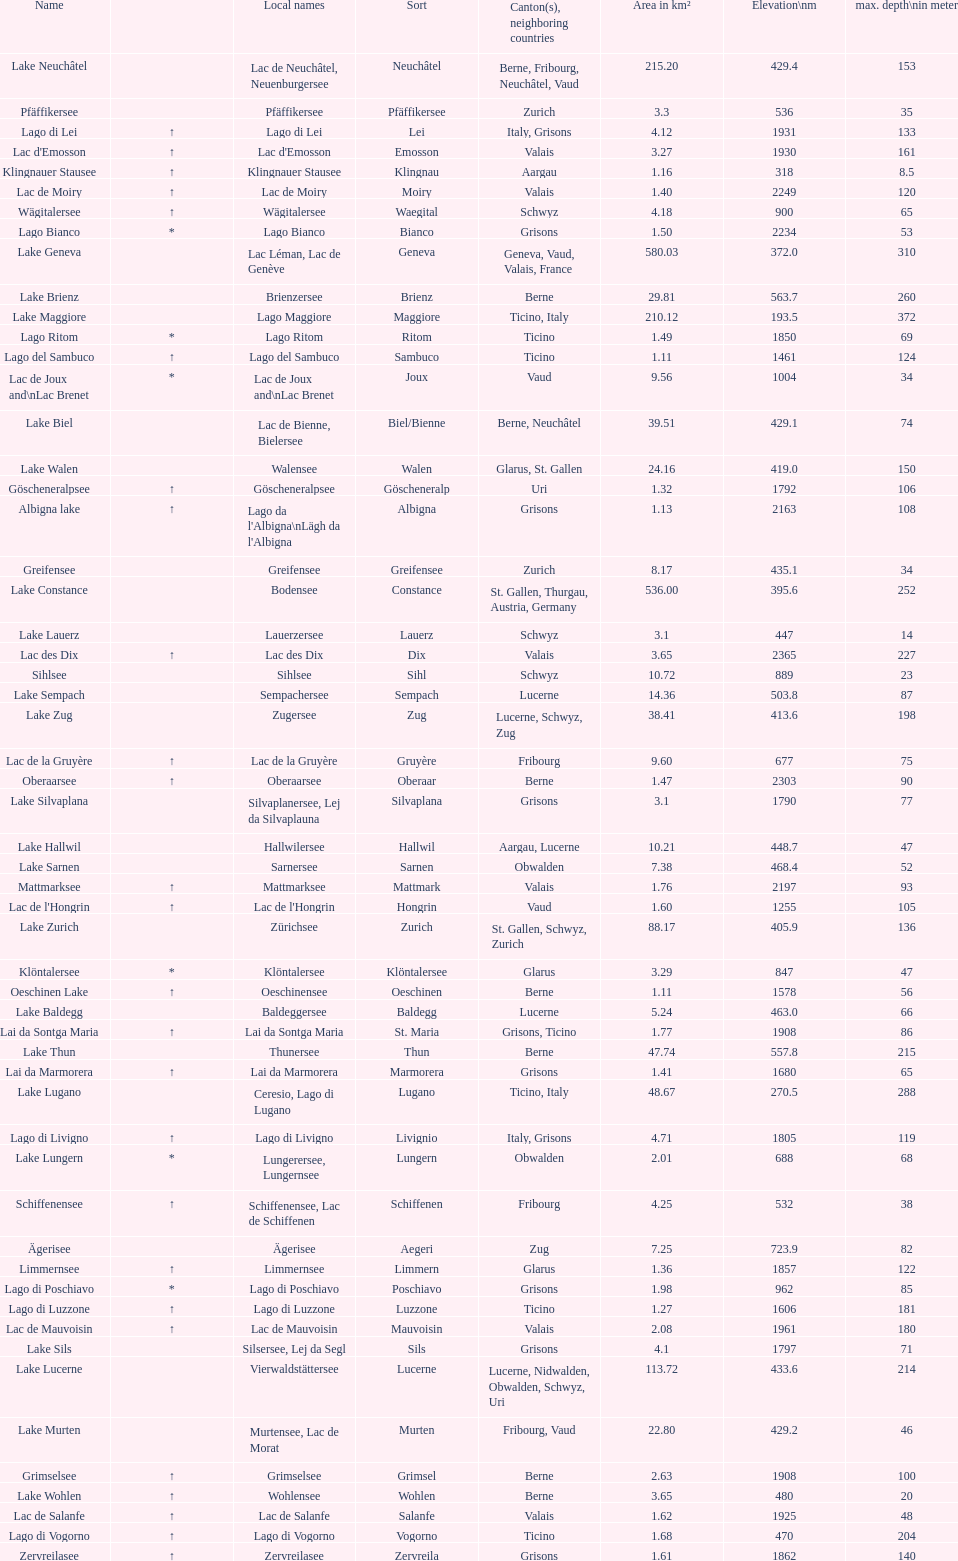Which lake has the largest elevation? Lac des Dix. 